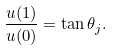<formula> <loc_0><loc_0><loc_500><loc_500>\frac { u ( 1 ) } { u ( 0 ) } = \tan \theta _ { j } .</formula> 